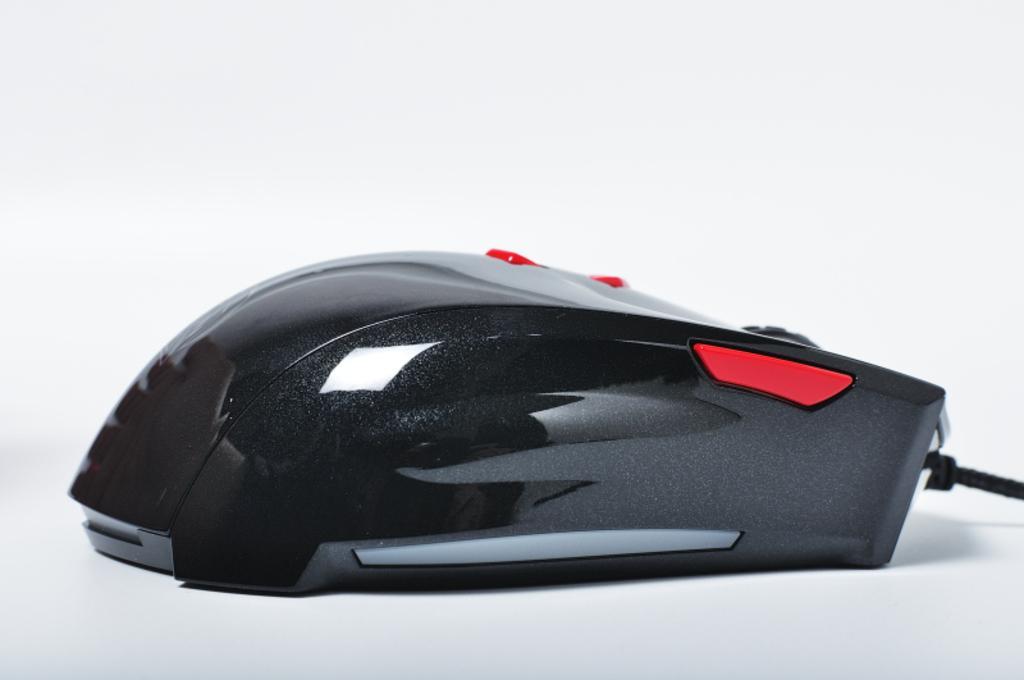Please provide a concise description of this image. In the picture there is a mouse, it is of black color. 